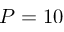<formula> <loc_0><loc_0><loc_500><loc_500>P = 1 0</formula> 